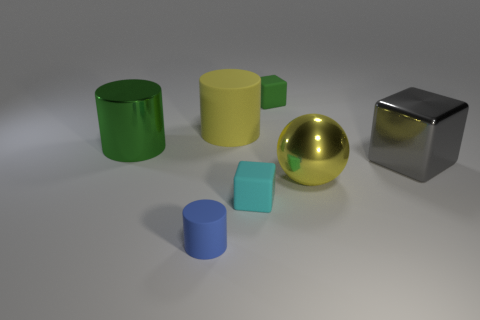Add 2 big green cylinders. How many objects exist? 9 Subtract all balls. How many objects are left? 6 Add 3 small cyan things. How many small cyan things are left? 4 Add 1 yellow balls. How many yellow balls exist? 2 Subtract 0 purple spheres. How many objects are left? 7 Subtract all large shiny things. Subtract all small blue objects. How many objects are left? 3 